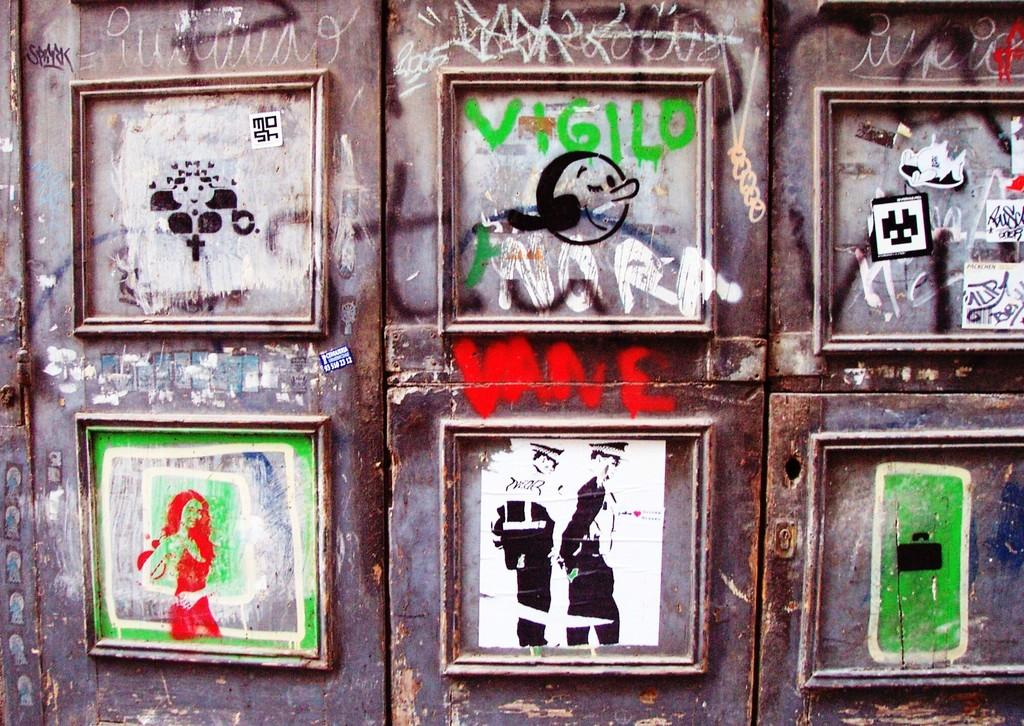What is the main object in the image? There is a door in the image. What can be seen on the door? The door has pictures on it and written text. How does the cook twist the class in the image? There is no cook, twist, or class present in the image; it only features a door with pictures and written text. 